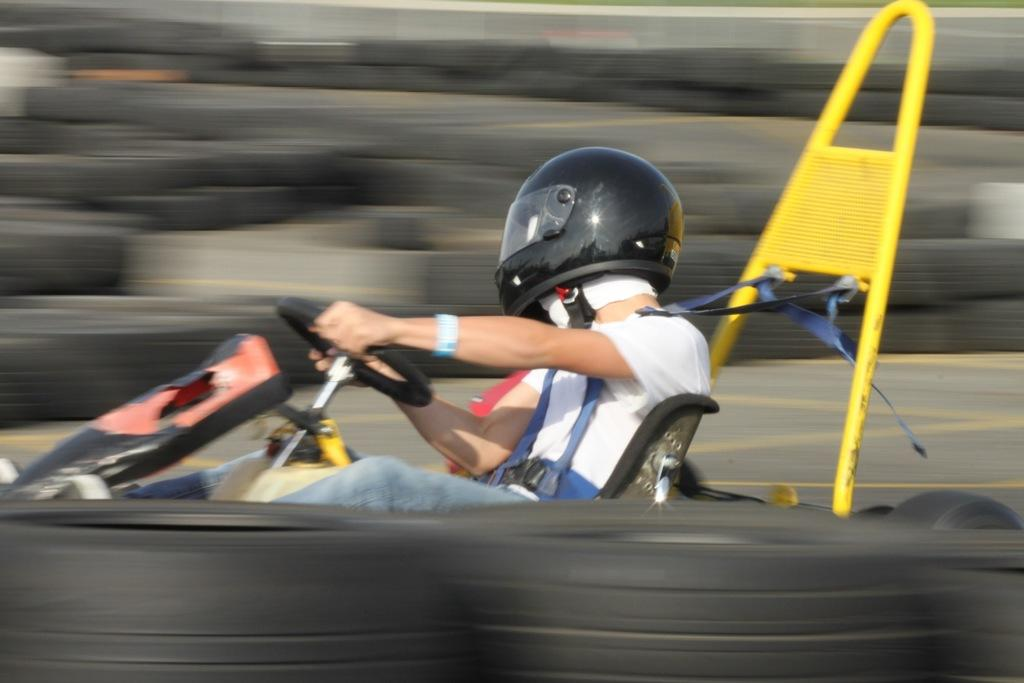What is the main subject of the image? The main subject of the image is a person driving a go kart. Can you describe the surroundings of the person in the image? Unfortunately, the edges of the image are blurred, so it is difficult to provide a detailed description of the surroundings. What type of sea creature can be seen swimming near the go kart in the image? There is no sea creature present in the image, as it features a person driving a go kart on a land-based track. Is the go kart driver teaching a class in the image? There is no indication in the image that the go kart driver is teaching a class, as the focus is on the person driving the go kart. 